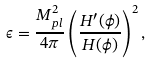Convert formula to latex. <formula><loc_0><loc_0><loc_500><loc_500>\epsilon = \frac { M _ { p l } ^ { 2 } } { 4 \pi } \left ( \frac { H ^ { \prime } ( \phi ) } { H ( \phi ) } \right ) ^ { 2 } ,</formula> 